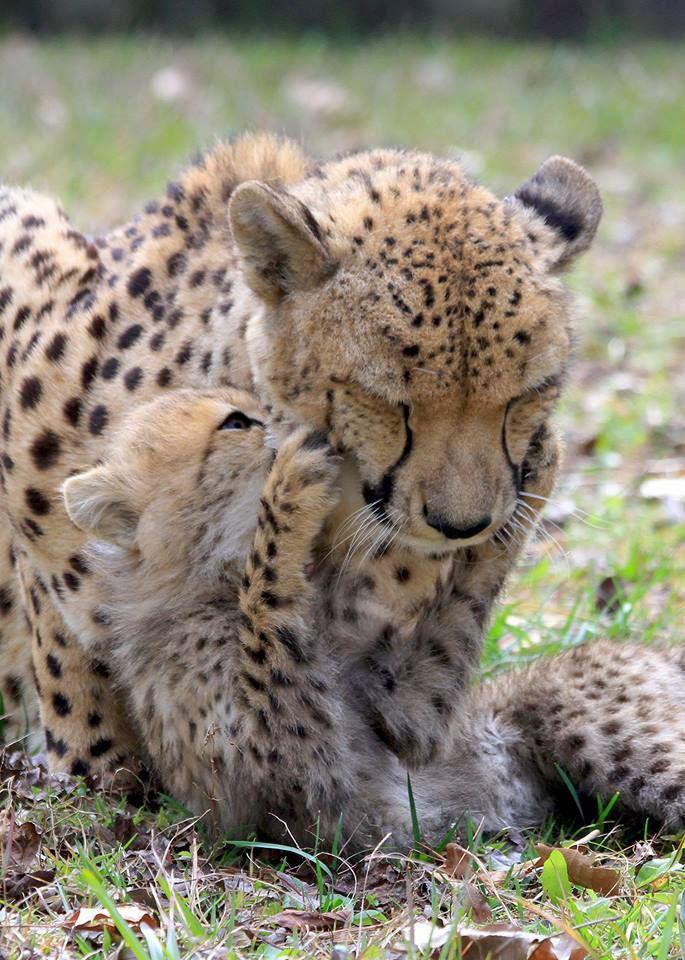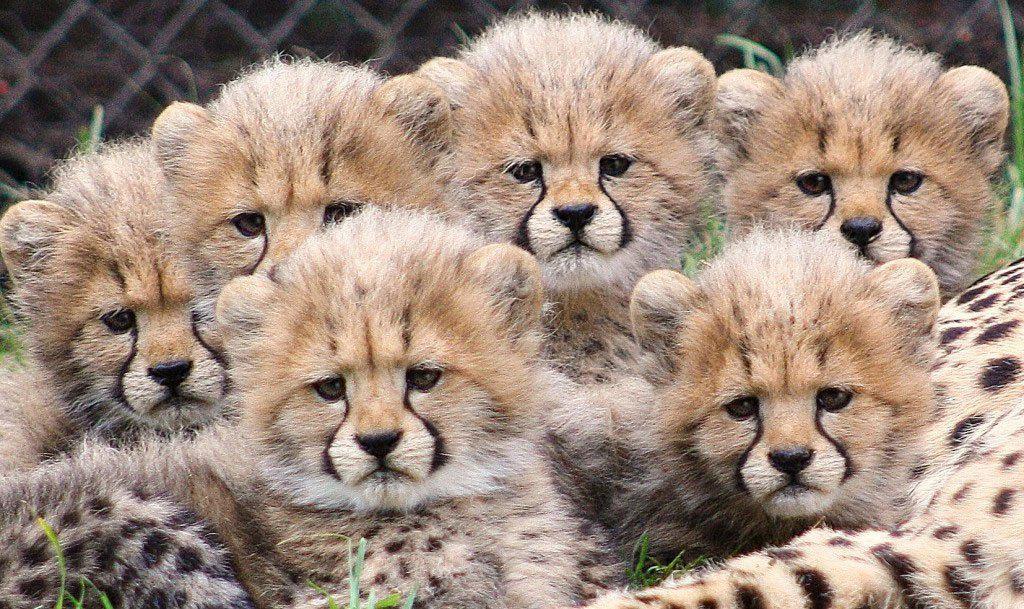The first image is the image on the left, the second image is the image on the right. Analyze the images presented: Is the assertion "There are exactly eight cheetahs." valid? Answer yes or no. Yes. The first image is the image on the left, the second image is the image on the right. Analyze the images presented: Is the assertion "An image contains only a non-standing adult wild cat and one kitten, posed with their faces close together." valid? Answer yes or no. Yes. 